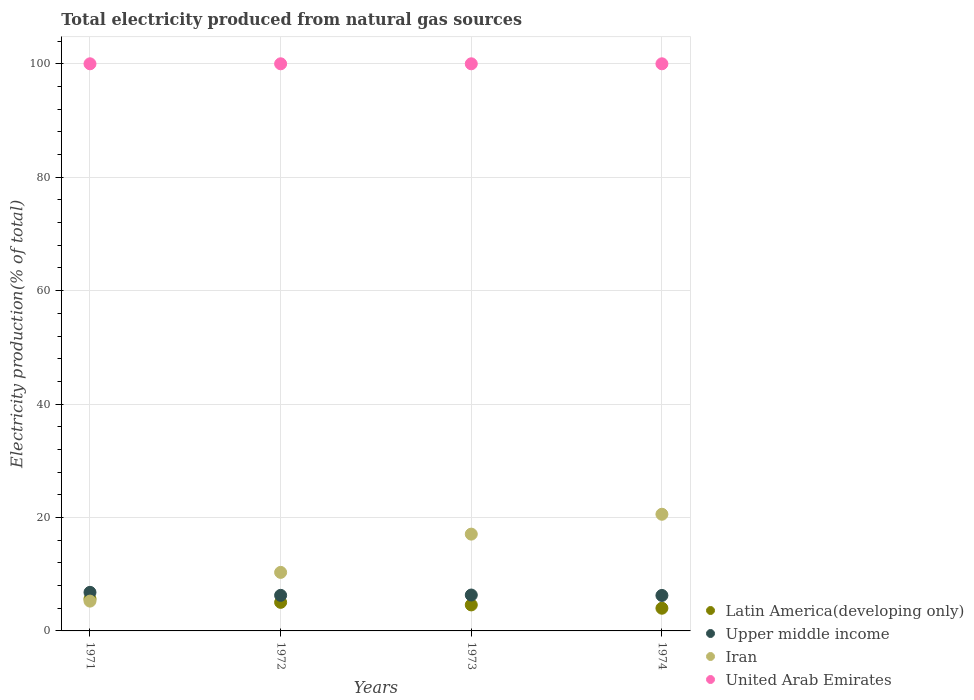Is the number of dotlines equal to the number of legend labels?
Your response must be concise. Yes. What is the total electricity produced in Latin America(developing only) in 1974?
Give a very brief answer. 4. Across all years, what is the maximum total electricity produced in Iran?
Provide a short and direct response. 20.57. Across all years, what is the minimum total electricity produced in Iran?
Make the answer very short. 5.26. In which year was the total electricity produced in Latin America(developing only) minimum?
Make the answer very short. 1974. What is the total total electricity produced in Upper middle income in the graph?
Your response must be concise. 25.66. What is the difference between the total electricity produced in Iran in 1971 and that in 1972?
Give a very brief answer. -5.07. What is the difference between the total electricity produced in Upper middle income in 1973 and the total electricity produced in Latin America(developing only) in 1972?
Make the answer very short. 1.29. What is the average total electricity produced in Iran per year?
Your response must be concise. 13.3. In the year 1973, what is the difference between the total electricity produced in Upper middle income and total electricity produced in Latin America(developing only)?
Your answer should be very brief. 1.74. In how many years, is the total electricity produced in Upper middle income greater than 80 %?
Provide a succinct answer. 0. What is the ratio of the total electricity produced in Iran in 1972 to that in 1973?
Your response must be concise. 0.6. Is the difference between the total electricity produced in Upper middle income in 1972 and 1974 greater than the difference between the total electricity produced in Latin America(developing only) in 1972 and 1974?
Keep it short and to the point. No. What is the difference between the highest and the second highest total electricity produced in Iran?
Offer a terse response. 3.5. In how many years, is the total electricity produced in Iran greater than the average total electricity produced in Iran taken over all years?
Give a very brief answer. 2. Is the sum of the total electricity produced in Upper middle income in 1972 and 1974 greater than the maximum total electricity produced in Iran across all years?
Make the answer very short. No. Is it the case that in every year, the sum of the total electricity produced in Upper middle income and total electricity produced in Iran  is greater than the sum of total electricity produced in United Arab Emirates and total electricity produced in Latin America(developing only)?
Provide a succinct answer. Yes. Does the total electricity produced in Upper middle income monotonically increase over the years?
Give a very brief answer. No. Is the total electricity produced in United Arab Emirates strictly greater than the total electricity produced in Iran over the years?
Your answer should be very brief. Yes. Is the total electricity produced in United Arab Emirates strictly less than the total electricity produced in Upper middle income over the years?
Provide a succinct answer. No. How many dotlines are there?
Provide a short and direct response. 4. What is the difference between two consecutive major ticks on the Y-axis?
Provide a short and direct response. 20. Does the graph contain any zero values?
Ensure brevity in your answer.  No. Does the graph contain grids?
Provide a succinct answer. Yes. Where does the legend appear in the graph?
Make the answer very short. Bottom right. How many legend labels are there?
Your answer should be compact. 4. What is the title of the graph?
Offer a very short reply. Total electricity produced from natural gas sources. What is the Electricity production(% of total) in Latin America(developing only) in 1971?
Ensure brevity in your answer.  5.65. What is the Electricity production(% of total) of Upper middle income in 1971?
Your answer should be very brief. 6.8. What is the Electricity production(% of total) in Iran in 1971?
Your answer should be very brief. 5.26. What is the Electricity production(% of total) of Latin America(developing only) in 1972?
Provide a succinct answer. 5.04. What is the Electricity production(% of total) in Upper middle income in 1972?
Give a very brief answer. 6.27. What is the Electricity production(% of total) of Iran in 1972?
Offer a very short reply. 10.32. What is the Electricity production(% of total) in United Arab Emirates in 1972?
Your answer should be very brief. 100. What is the Electricity production(% of total) in Latin America(developing only) in 1973?
Offer a very short reply. 4.58. What is the Electricity production(% of total) of Upper middle income in 1973?
Your answer should be very brief. 6.33. What is the Electricity production(% of total) in Iran in 1973?
Your response must be concise. 17.07. What is the Electricity production(% of total) of Latin America(developing only) in 1974?
Offer a very short reply. 4. What is the Electricity production(% of total) in Upper middle income in 1974?
Your answer should be very brief. 6.25. What is the Electricity production(% of total) in Iran in 1974?
Provide a short and direct response. 20.57. What is the Electricity production(% of total) of United Arab Emirates in 1974?
Your response must be concise. 100. Across all years, what is the maximum Electricity production(% of total) of Latin America(developing only)?
Ensure brevity in your answer.  5.65. Across all years, what is the maximum Electricity production(% of total) in Upper middle income?
Keep it short and to the point. 6.8. Across all years, what is the maximum Electricity production(% of total) of Iran?
Provide a short and direct response. 20.57. Across all years, what is the maximum Electricity production(% of total) of United Arab Emirates?
Offer a terse response. 100. Across all years, what is the minimum Electricity production(% of total) of Latin America(developing only)?
Your answer should be compact. 4. Across all years, what is the minimum Electricity production(% of total) in Upper middle income?
Your answer should be compact. 6.25. Across all years, what is the minimum Electricity production(% of total) of Iran?
Provide a short and direct response. 5.26. Across all years, what is the minimum Electricity production(% of total) of United Arab Emirates?
Ensure brevity in your answer.  100. What is the total Electricity production(% of total) in Latin America(developing only) in the graph?
Offer a terse response. 19.27. What is the total Electricity production(% of total) of Upper middle income in the graph?
Keep it short and to the point. 25.66. What is the total Electricity production(% of total) of Iran in the graph?
Offer a very short reply. 53.22. What is the total Electricity production(% of total) in United Arab Emirates in the graph?
Make the answer very short. 400. What is the difference between the Electricity production(% of total) of Latin America(developing only) in 1971 and that in 1972?
Give a very brief answer. 0.61. What is the difference between the Electricity production(% of total) in Upper middle income in 1971 and that in 1972?
Provide a succinct answer. 0.53. What is the difference between the Electricity production(% of total) in Iran in 1971 and that in 1972?
Provide a short and direct response. -5.07. What is the difference between the Electricity production(% of total) in United Arab Emirates in 1971 and that in 1972?
Provide a short and direct response. 0. What is the difference between the Electricity production(% of total) in Latin America(developing only) in 1971 and that in 1973?
Your answer should be compact. 1.06. What is the difference between the Electricity production(% of total) in Upper middle income in 1971 and that in 1973?
Ensure brevity in your answer.  0.47. What is the difference between the Electricity production(% of total) in Iran in 1971 and that in 1973?
Your answer should be compact. -11.81. What is the difference between the Electricity production(% of total) of United Arab Emirates in 1971 and that in 1973?
Your answer should be compact. 0. What is the difference between the Electricity production(% of total) of Latin America(developing only) in 1971 and that in 1974?
Provide a succinct answer. 1.65. What is the difference between the Electricity production(% of total) of Upper middle income in 1971 and that in 1974?
Offer a very short reply. 0.55. What is the difference between the Electricity production(% of total) in Iran in 1971 and that in 1974?
Make the answer very short. -15.32. What is the difference between the Electricity production(% of total) in United Arab Emirates in 1971 and that in 1974?
Offer a very short reply. 0. What is the difference between the Electricity production(% of total) in Latin America(developing only) in 1972 and that in 1973?
Ensure brevity in your answer.  0.45. What is the difference between the Electricity production(% of total) in Upper middle income in 1972 and that in 1973?
Your response must be concise. -0.06. What is the difference between the Electricity production(% of total) in Iran in 1972 and that in 1973?
Give a very brief answer. -6.75. What is the difference between the Electricity production(% of total) in Latin America(developing only) in 1972 and that in 1974?
Your answer should be very brief. 1.04. What is the difference between the Electricity production(% of total) in Upper middle income in 1972 and that in 1974?
Offer a terse response. 0.02. What is the difference between the Electricity production(% of total) in Iran in 1972 and that in 1974?
Offer a terse response. -10.25. What is the difference between the Electricity production(% of total) in United Arab Emirates in 1972 and that in 1974?
Offer a terse response. 0. What is the difference between the Electricity production(% of total) in Latin America(developing only) in 1973 and that in 1974?
Ensure brevity in your answer.  0.58. What is the difference between the Electricity production(% of total) of Upper middle income in 1973 and that in 1974?
Offer a very short reply. 0.07. What is the difference between the Electricity production(% of total) in Iran in 1973 and that in 1974?
Provide a short and direct response. -3.5. What is the difference between the Electricity production(% of total) in Latin America(developing only) in 1971 and the Electricity production(% of total) in Upper middle income in 1972?
Make the answer very short. -0.63. What is the difference between the Electricity production(% of total) of Latin America(developing only) in 1971 and the Electricity production(% of total) of Iran in 1972?
Offer a very short reply. -4.67. What is the difference between the Electricity production(% of total) in Latin America(developing only) in 1971 and the Electricity production(% of total) in United Arab Emirates in 1972?
Your response must be concise. -94.35. What is the difference between the Electricity production(% of total) in Upper middle income in 1971 and the Electricity production(% of total) in Iran in 1972?
Your response must be concise. -3.52. What is the difference between the Electricity production(% of total) of Upper middle income in 1971 and the Electricity production(% of total) of United Arab Emirates in 1972?
Keep it short and to the point. -93.2. What is the difference between the Electricity production(% of total) of Iran in 1971 and the Electricity production(% of total) of United Arab Emirates in 1972?
Your answer should be compact. -94.74. What is the difference between the Electricity production(% of total) of Latin America(developing only) in 1971 and the Electricity production(% of total) of Upper middle income in 1973?
Your answer should be compact. -0.68. What is the difference between the Electricity production(% of total) of Latin America(developing only) in 1971 and the Electricity production(% of total) of Iran in 1973?
Your answer should be compact. -11.42. What is the difference between the Electricity production(% of total) of Latin America(developing only) in 1971 and the Electricity production(% of total) of United Arab Emirates in 1973?
Keep it short and to the point. -94.35. What is the difference between the Electricity production(% of total) of Upper middle income in 1971 and the Electricity production(% of total) of Iran in 1973?
Keep it short and to the point. -10.27. What is the difference between the Electricity production(% of total) of Upper middle income in 1971 and the Electricity production(% of total) of United Arab Emirates in 1973?
Ensure brevity in your answer.  -93.2. What is the difference between the Electricity production(% of total) in Iran in 1971 and the Electricity production(% of total) in United Arab Emirates in 1973?
Offer a terse response. -94.74. What is the difference between the Electricity production(% of total) in Latin America(developing only) in 1971 and the Electricity production(% of total) in Upper middle income in 1974?
Offer a terse response. -0.61. What is the difference between the Electricity production(% of total) of Latin America(developing only) in 1971 and the Electricity production(% of total) of Iran in 1974?
Give a very brief answer. -14.92. What is the difference between the Electricity production(% of total) in Latin America(developing only) in 1971 and the Electricity production(% of total) in United Arab Emirates in 1974?
Provide a succinct answer. -94.35. What is the difference between the Electricity production(% of total) in Upper middle income in 1971 and the Electricity production(% of total) in Iran in 1974?
Provide a short and direct response. -13.77. What is the difference between the Electricity production(% of total) in Upper middle income in 1971 and the Electricity production(% of total) in United Arab Emirates in 1974?
Give a very brief answer. -93.2. What is the difference between the Electricity production(% of total) of Iran in 1971 and the Electricity production(% of total) of United Arab Emirates in 1974?
Offer a very short reply. -94.74. What is the difference between the Electricity production(% of total) in Latin America(developing only) in 1972 and the Electricity production(% of total) in Upper middle income in 1973?
Your answer should be compact. -1.29. What is the difference between the Electricity production(% of total) of Latin America(developing only) in 1972 and the Electricity production(% of total) of Iran in 1973?
Give a very brief answer. -12.03. What is the difference between the Electricity production(% of total) in Latin America(developing only) in 1972 and the Electricity production(% of total) in United Arab Emirates in 1973?
Keep it short and to the point. -94.96. What is the difference between the Electricity production(% of total) of Upper middle income in 1972 and the Electricity production(% of total) of Iran in 1973?
Provide a short and direct response. -10.79. What is the difference between the Electricity production(% of total) of Upper middle income in 1972 and the Electricity production(% of total) of United Arab Emirates in 1973?
Offer a terse response. -93.73. What is the difference between the Electricity production(% of total) of Iran in 1972 and the Electricity production(% of total) of United Arab Emirates in 1973?
Your response must be concise. -89.68. What is the difference between the Electricity production(% of total) of Latin America(developing only) in 1972 and the Electricity production(% of total) of Upper middle income in 1974?
Provide a succinct answer. -1.22. What is the difference between the Electricity production(% of total) in Latin America(developing only) in 1972 and the Electricity production(% of total) in Iran in 1974?
Provide a succinct answer. -15.53. What is the difference between the Electricity production(% of total) in Latin America(developing only) in 1972 and the Electricity production(% of total) in United Arab Emirates in 1974?
Offer a terse response. -94.96. What is the difference between the Electricity production(% of total) in Upper middle income in 1972 and the Electricity production(% of total) in Iran in 1974?
Ensure brevity in your answer.  -14.3. What is the difference between the Electricity production(% of total) in Upper middle income in 1972 and the Electricity production(% of total) in United Arab Emirates in 1974?
Your response must be concise. -93.73. What is the difference between the Electricity production(% of total) in Iran in 1972 and the Electricity production(% of total) in United Arab Emirates in 1974?
Offer a terse response. -89.68. What is the difference between the Electricity production(% of total) in Latin America(developing only) in 1973 and the Electricity production(% of total) in Upper middle income in 1974?
Your answer should be very brief. -1.67. What is the difference between the Electricity production(% of total) in Latin America(developing only) in 1973 and the Electricity production(% of total) in Iran in 1974?
Your answer should be very brief. -15.99. What is the difference between the Electricity production(% of total) in Latin America(developing only) in 1973 and the Electricity production(% of total) in United Arab Emirates in 1974?
Offer a terse response. -95.42. What is the difference between the Electricity production(% of total) in Upper middle income in 1973 and the Electricity production(% of total) in Iran in 1974?
Give a very brief answer. -14.24. What is the difference between the Electricity production(% of total) of Upper middle income in 1973 and the Electricity production(% of total) of United Arab Emirates in 1974?
Offer a very short reply. -93.67. What is the difference between the Electricity production(% of total) in Iran in 1973 and the Electricity production(% of total) in United Arab Emirates in 1974?
Provide a succinct answer. -82.93. What is the average Electricity production(% of total) of Latin America(developing only) per year?
Ensure brevity in your answer.  4.82. What is the average Electricity production(% of total) in Upper middle income per year?
Offer a terse response. 6.41. What is the average Electricity production(% of total) in Iran per year?
Make the answer very short. 13.3. In the year 1971, what is the difference between the Electricity production(% of total) of Latin America(developing only) and Electricity production(% of total) of Upper middle income?
Offer a very short reply. -1.15. In the year 1971, what is the difference between the Electricity production(% of total) in Latin America(developing only) and Electricity production(% of total) in Iran?
Make the answer very short. 0.39. In the year 1971, what is the difference between the Electricity production(% of total) of Latin America(developing only) and Electricity production(% of total) of United Arab Emirates?
Offer a terse response. -94.35. In the year 1971, what is the difference between the Electricity production(% of total) of Upper middle income and Electricity production(% of total) of Iran?
Your answer should be very brief. 1.55. In the year 1971, what is the difference between the Electricity production(% of total) in Upper middle income and Electricity production(% of total) in United Arab Emirates?
Your response must be concise. -93.2. In the year 1971, what is the difference between the Electricity production(% of total) of Iran and Electricity production(% of total) of United Arab Emirates?
Provide a succinct answer. -94.74. In the year 1972, what is the difference between the Electricity production(% of total) of Latin America(developing only) and Electricity production(% of total) of Upper middle income?
Ensure brevity in your answer.  -1.24. In the year 1972, what is the difference between the Electricity production(% of total) of Latin America(developing only) and Electricity production(% of total) of Iran?
Ensure brevity in your answer.  -5.28. In the year 1972, what is the difference between the Electricity production(% of total) of Latin America(developing only) and Electricity production(% of total) of United Arab Emirates?
Give a very brief answer. -94.96. In the year 1972, what is the difference between the Electricity production(% of total) in Upper middle income and Electricity production(% of total) in Iran?
Offer a terse response. -4.05. In the year 1972, what is the difference between the Electricity production(% of total) of Upper middle income and Electricity production(% of total) of United Arab Emirates?
Keep it short and to the point. -93.73. In the year 1972, what is the difference between the Electricity production(% of total) in Iran and Electricity production(% of total) in United Arab Emirates?
Offer a very short reply. -89.68. In the year 1973, what is the difference between the Electricity production(% of total) in Latin America(developing only) and Electricity production(% of total) in Upper middle income?
Keep it short and to the point. -1.74. In the year 1973, what is the difference between the Electricity production(% of total) of Latin America(developing only) and Electricity production(% of total) of Iran?
Keep it short and to the point. -12.48. In the year 1973, what is the difference between the Electricity production(% of total) of Latin America(developing only) and Electricity production(% of total) of United Arab Emirates?
Your response must be concise. -95.42. In the year 1973, what is the difference between the Electricity production(% of total) in Upper middle income and Electricity production(% of total) in Iran?
Make the answer very short. -10.74. In the year 1973, what is the difference between the Electricity production(% of total) in Upper middle income and Electricity production(% of total) in United Arab Emirates?
Your answer should be very brief. -93.67. In the year 1973, what is the difference between the Electricity production(% of total) in Iran and Electricity production(% of total) in United Arab Emirates?
Make the answer very short. -82.93. In the year 1974, what is the difference between the Electricity production(% of total) in Latin America(developing only) and Electricity production(% of total) in Upper middle income?
Provide a short and direct response. -2.25. In the year 1974, what is the difference between the Electricity production(% of total) of Latin America(developing only) and Electricity production(% of total) of Iran?
Your answer should be very brief. -16.57. In the year 1974, what is the difference between the Electricity production(% of total) in Latin America(developing only) and Electricity production(% of total) in United Arab Emirates?
Give a very brief answer. -96. In the year 1974, what is the difference between the Electricity production(% of total) of Upper middle income and Electricity production(% of total) of Iran?
Offer a very short reply. -14.32. In the year 1974, what is the difference between the Electricity production(% of total) in Upper middle income and Electricity production(% of total) in United Arab Emirates?
Your answer should be very brief. -93.75. In the year 1974, what is the difference between the Electricity production(% of total) in Iran and Electricity production(% of total) in United Arab Emirates?
Your answer should be very brief. -79.43. What is the ratio of the Electricity production(% of total) of Latin America(developing only) in 1971 to that in 1972?
Your response must be concise. 1.12. What is the ratio of the Electricity production(% of total) in Upper middle income in 1971 to that in 1972?
Provide a short and direct response. 1.08. What is the ratio of the Electricity production(% of total) in Iran in 1971 to that in 1972?
Provide a succinct answer. 0.51. What is the ratio of the Electricity production(% of total) in United Arab Emirates in 1971 to that in 1972?
Provide a short and direct response. 1. What is the ratio of the Electricity production(% of total) of Latin America(developing only) in 1971 to that in 1973?
Provide a short and direct response. 1.23. What is the ratio of the Electricity production(% of total) in Upper middle income in 1971 to that in 1973?
Make the answer very short. 1.07. What is the ratio of the Electricity production(% of total) in Iran in 1971 to that in 1973?
Keep it short and to the point. 0.31. What is the ratio of the Electricity production(% of total) of United Arab Emirates in 1971 to that in 1973?
Your answer should be compact. 1. What is the ratio of the Electricity production(% of total) in Latin America(developing only) in 1971 to that in 1974?
Offer a very short reply. 1.41. What is the ratio of the Electricity production(% of total) in Upper middle income in 1971 to that in 1974?
Provide a short and direct response. 1.09. What is the ratio of the Electricity production(% of total) in Iran in 1971 to that in 1974?
Keep it short and to the point. 0.26. What is the ratio of the Electricity production(% of total) in Latin America(developing only) in 1972 to that in 1973?
Your answer should be very brief. 1.1. What is the ratio of the Electricity production(% of total) in Upper middle income in 1972 to that in 1973?
Ensure brevity in your answer.  0.99. What is the ratio of the Electricity production(% of total) of Iran in 1972 to that in 1973?
Your answer should be compact. 0.6. What is the ratio of the Electricity production(% of total) of Latin America(developing only) in 1972 to that in 1974?
Provide a short and direct response. 1.26. What is the ratio of the Electricity production(% of total) in Iran in 1972 to that in 1974?
Provide a succinct answer. 0.5. What is the ratio of the Electricity production(% of total) of Latin America(developing only) in 1973 to that in 1974?
Give a very brief answer. 1.15. What is the ratio of the Electricity production(% of total) in Iran in 1973 to that in 1974?
Offer a terse response. 0.83. What is the difference between the highest and the second highest Electricity production(% of total) in Latin America(developing only)?
Provide a short and direct response. 0.61. What is the difference between the highest and the second highest Electricity production(% of total) of Upper middle income?
Give a very brief answer. 0.47. What is the difference between the highest and the second highest Electricity production(% of total) in Iran?
Provide a succinct answer. 3.5. What is the difference between the highest and the second highest Electricity production(% of total) of United Arab Emirates?
Keep it short and to the point. 0. What is the difference between the highest and the lowest Electricity production(% of total) in Latin America(developing only)?
Provide a short and direct response. 1.65. What is the difference between the highest and the lowest Electricity production(% of total) of Upper middle income?
Offer a terse response. 0.55. What is the difference between the highest and the lowest Electricity production(% of total) in Iran?
Provide a succinct answer. 15.32. 